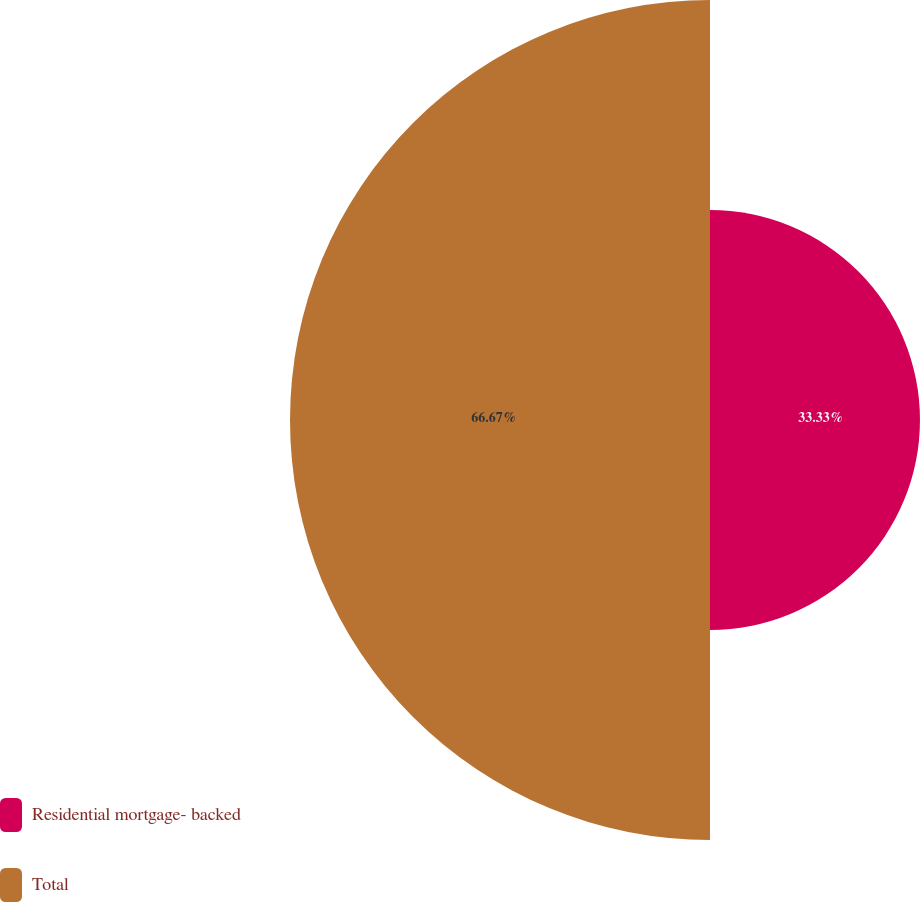Convert chart. <chart><loc_0><loc_0><loc_500><loc_500><pie_chart><fcel>Residential mortgage- backed<fcel>Total<nl><fcel>33.33%<fcel>66.67%<nl></chart> 